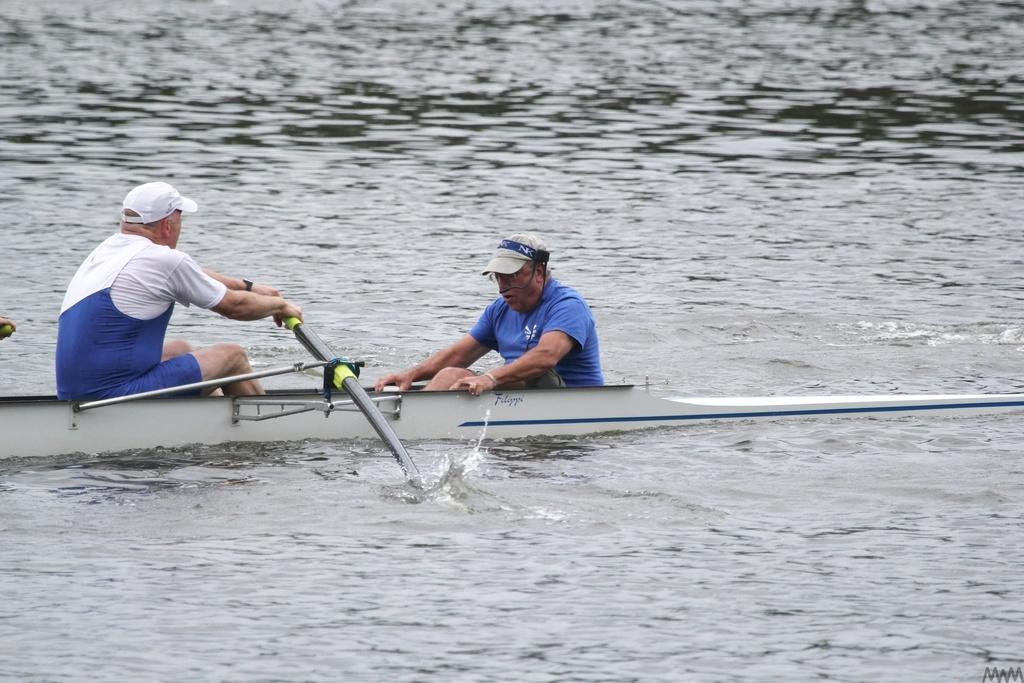Could you give a brief overview of what you see in this image? In this image there are two men who are sitting in the boat and rowing with the sticks. At the bottom there is water. 